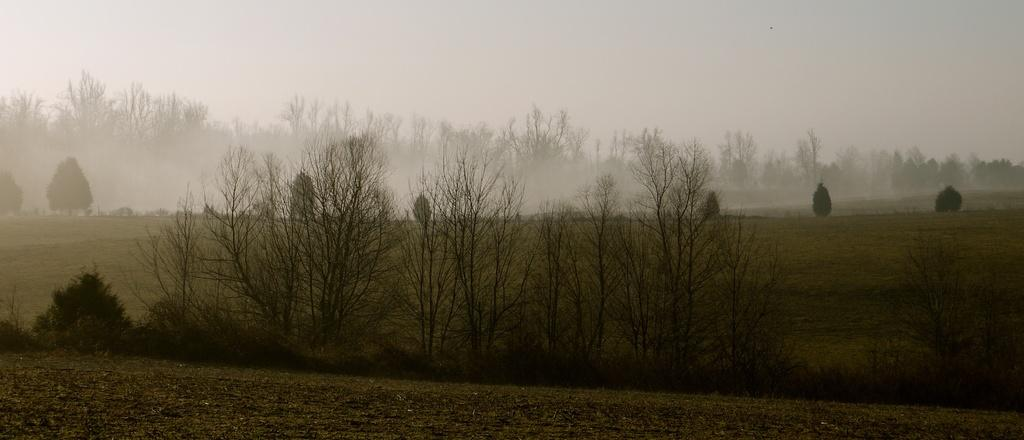What type of vegetation can be seen in the image? There are trees in the image. What is visible in the background of the image? The sky is visible in the background of the image. What type of sugar is being used by the lawyer in the image? There is no lawyer or sugar present in the image; it features trees and the sky. What type of rod can be seen in the image? There is no rod present in the image; it features trees and the sky. 